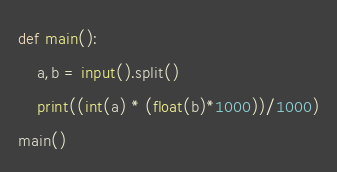Convert code to text. <code><loc_0><loc_0><loc_500><loc_500><_Python_>def main():
    a,b = input().split()
    print((int(a) * (float(b)*1000))/1000)
main()</code> 